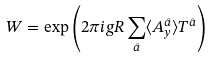<formula> <loc_0><loc_0><loc_500><loc_500>W = \exp \left ( 2 \pi i g R \sum _ { \hat { a } } \langle A ^ { \hat { a } } _ { y } \rangle T ^ { \hat { a } } \right )</formula> 